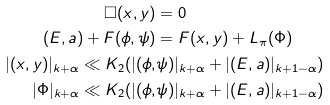<formula> <loc_0><loc_0><loc_500><loc_500>\Box ( x , y ) & = 0 \\ ( E , a ) + F ( \phi , \psi ) & = F ( x , y ) + L _ { \pi } ( \Phi ) \\ | ( x , y ) | _ { k + \alpha } \ll K _ { 2 } ( | ( \phi , & \psi ) | _ { k + \alpha } + | ( E , a ) | _ { k + 1 - \alpha } ) \\ | \Phi | _ { k + \alpha } \ll K _ { 2 } ( | ( \phi , & \psi ) | _ { k + \alpha } + | ( E , a ) | _ { k + 1 - \alpha } )</formula> 